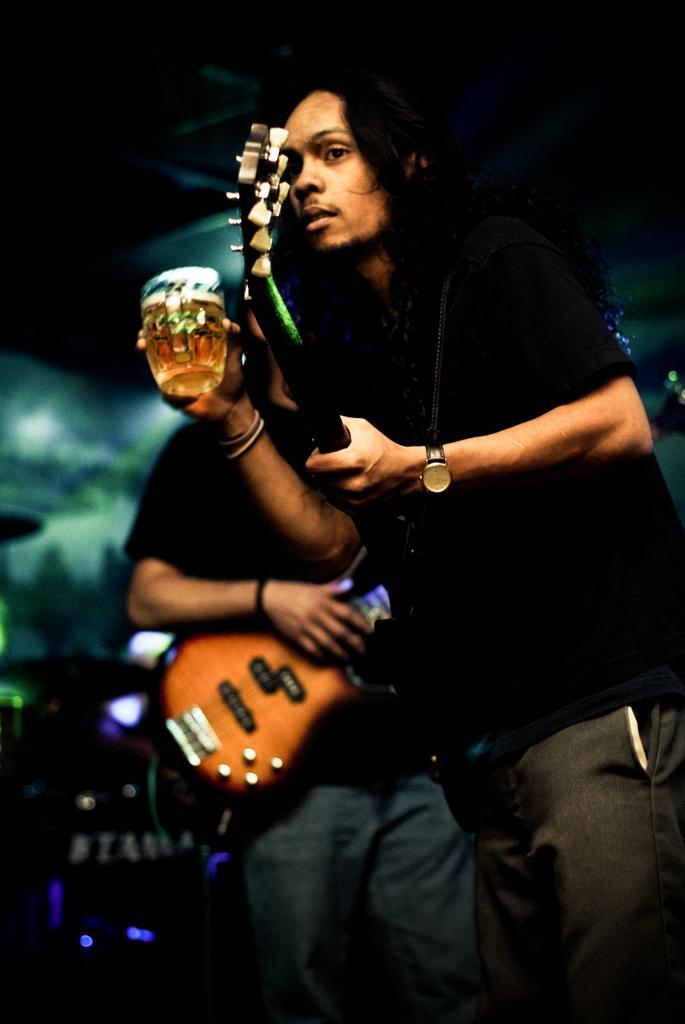Can you describe this image briefly? The man wearing a black t-shirt holding a guitar with watch on his left hand and beer mug on his right hand standing in front of man who also holding a guitar. The background has dim lights over some places. 